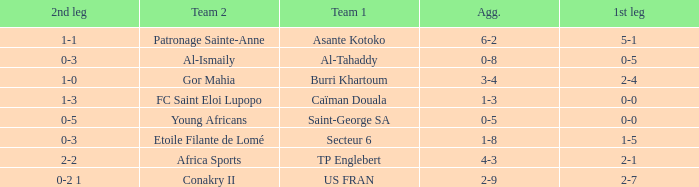Which team lost 0-3 and 0-5? Al-Tahaddy. 